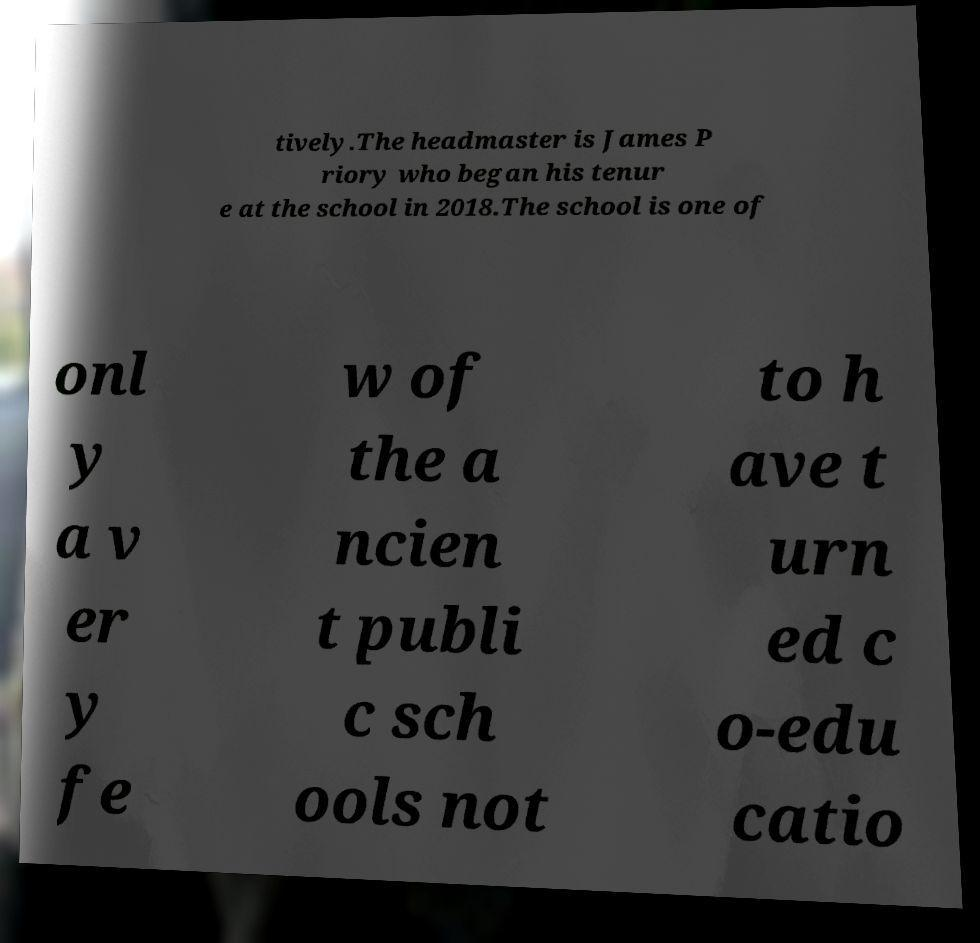Please identify and transcribe the text found in this image. tively.The headmaster is James P riory who began his tenur e at the school in 2018.The school is one of onl y a v er y fe w of the a ncien t publi c sch ools not to h ave t urn ed c o-edu catio 